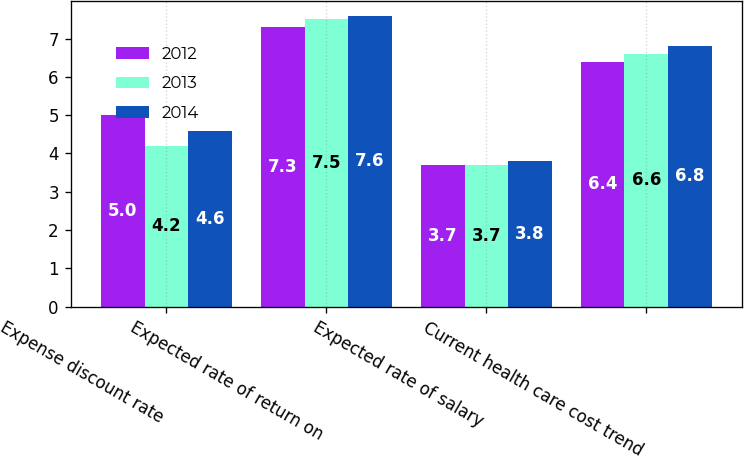Convert chart. <chart><loc_0><loc_0><loc_500><loc_500><stacked_bar_chart><ecel><fcel>Expense discount rate<fcel>Expected rate of return on<fcel>Expected rate of salary<fcel>Current health care cost trend<nl><fcel>2012<fcel>5<fcel>7.3<fcel>3.7<fcel>6.4<nl><fcel>2013<fcel>4.2<fcel>7.5<fcel>3.7<fcel>6.6<nl><fcel>2014<fcel>4.6<fcel>7.6<fcel>3.8<fcel>6.8<nl></chart> 